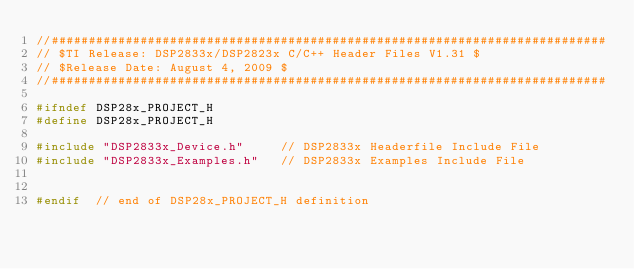<code> <loc_0><loc_0><loc_500><loc_500><_C_>//###########################################################################
// $TI Release: DSP2833x/DSP2823x C/C++ Header Files V1.31 $
// $Release Date: August 4, 2009 $
//###########################################################################

#ifndef DSP28x_PROJECT_H
#define DSP28x_PROJECT_H

#include "DSP2833x_Device.h"     // DSP2833x Headerfile Include File
#include "DSP2833x_Examples.h"   // DSP2833x Examples Include File


#endif  // end of DSP28x_PROJECT_H definition

</code> 